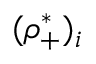Convert formula to latex. <formula><loc_0><loc_0><loc_500><loc_500>( \rho _ { + } ^ { * } ) _ { i }</formula> 